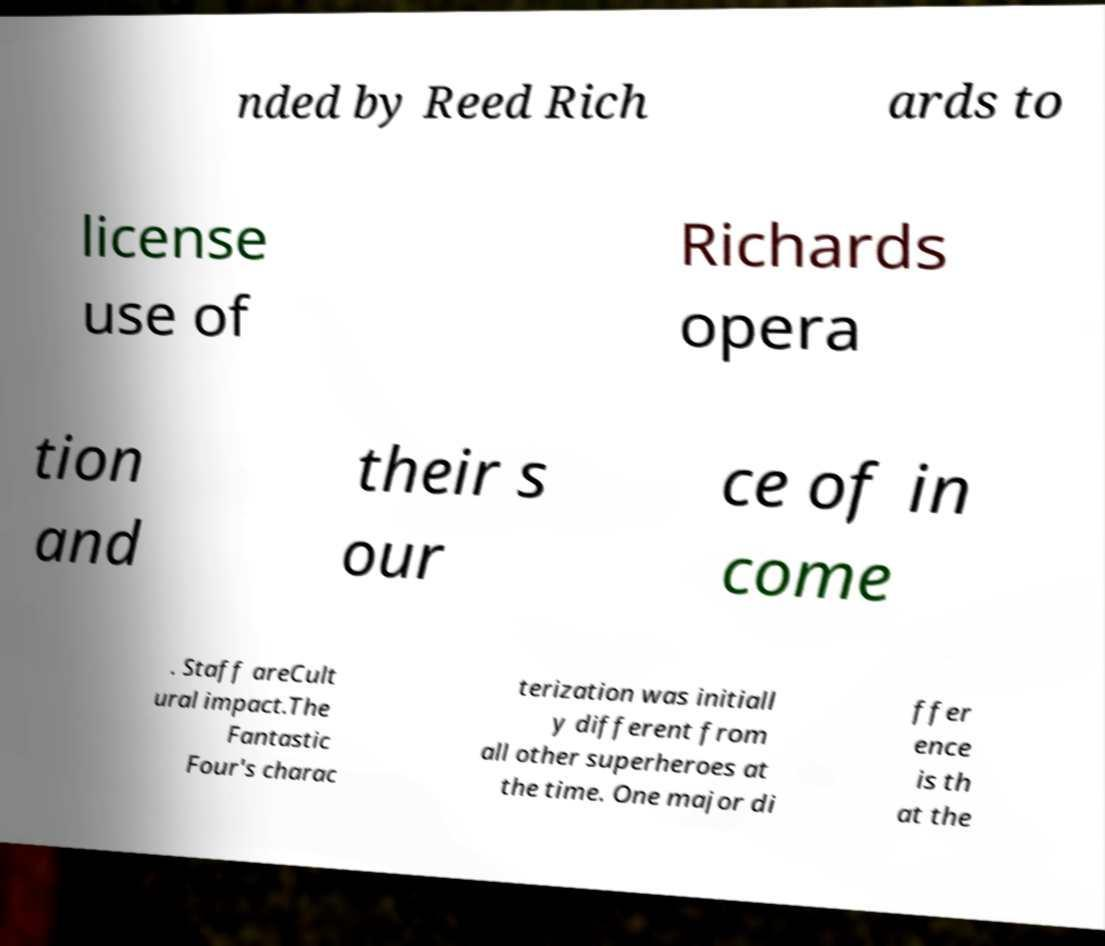There's text embedded in this image that I need extracted. Can you transcribe it verbatim? nded by Reed Rich ards to license use of Richards opera tion and their s our ce of in come . Staff areCult ural impact.The Fantastic Four's charac terization was initiall y different from all other superheroes at the time. One major di ffer ence is th at the 